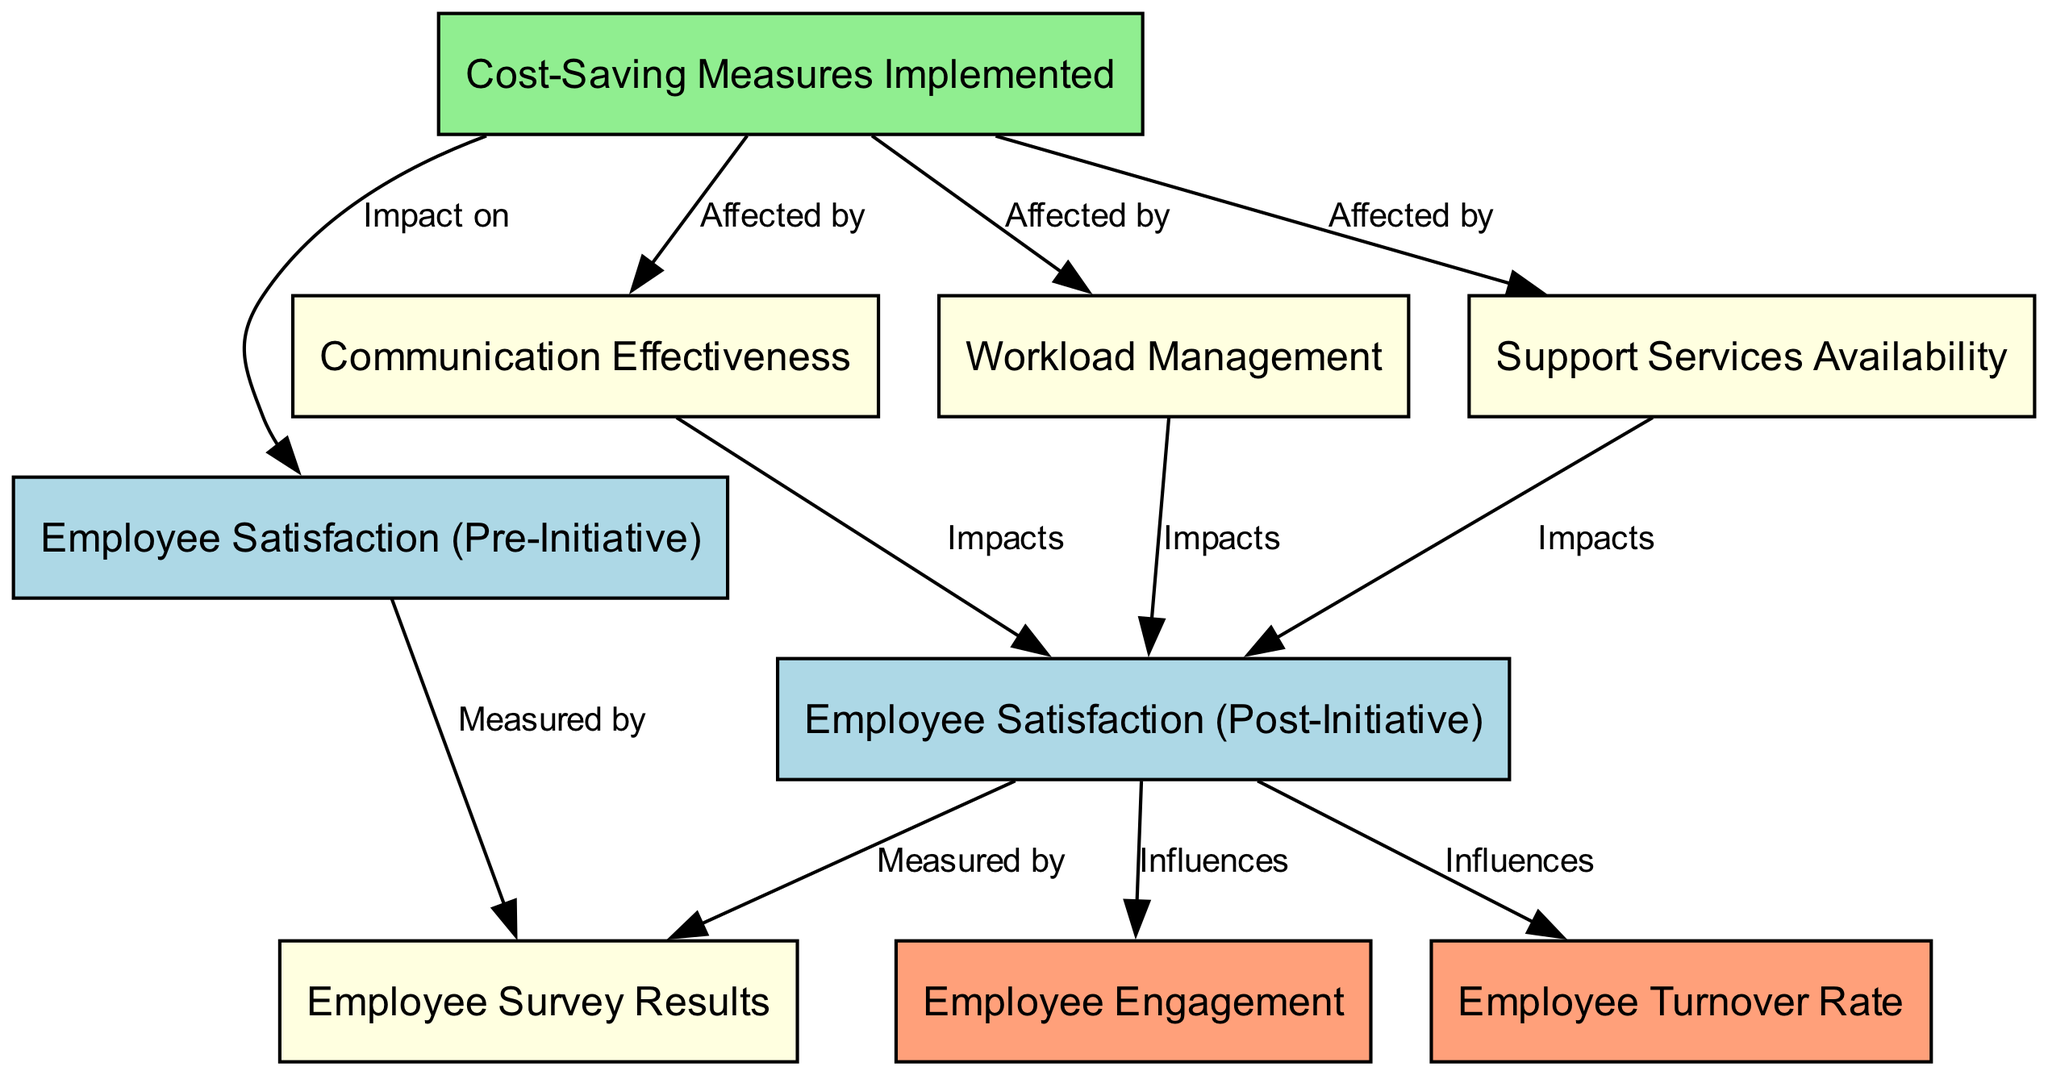What are the two main satisfaction levels represented in the diagram? The diagram represents two main satisfaction levels: employee satisfaction before the implementation of cost-saving initiatives and employee satisfaction after the implementation. These are identified as "Employee Satisfaction (Pre-Initiative)" and "Employee Satisfaction (Post-Initiative)" respectively.
Answer: Employee Satisfaction (Pre-Initiative), Employee Satisfaction (Post-Initiative) How many nodes are present in the diagram? To find the total number of nodes, we count each unique node listed in the 'nodes' section of the data. There are a total of nine nodes in the diagram.
Answer: 9 What is the relationship between cost-saving measures and pre-satisfaction? The diagram shows that cost-saving measures have an impact on pre-satisfaction. This is expressed with the edge labeled "Impact on" connecting "Cost-Saving Measures Implemented" to "Employee Satisfaction (Pre-Initiative)."
Answer: Impact on Which node influences employee engagement? The node that influences employee engagement is "Employee Satisfaction (Post-Initiative)." The diagram explicitly shows an edge leading from "Employee Satisfaction (Post-Initiative)" to "Employee Engagement" labeled "Influences."
Answer: Employee Satisfaction (Post-Initiative) What factors are affected by cost-saving measures? The diagram indicates three factors that are affected by cost-saving measures, represented by the edges leading to "Communication Effectiveness," "Workload Management," and "Support Services Availability." Therefore, all three are directly influenced by the cost-saving measures.
Answer: Communication Effectiveness, Workload Management, Support Services Availability How does communication effectiveness impact post-satisfaction? Communication effectiveness impacts post-satisfaction as shown by the edge connecting the two nodes in the diagram, labeled "Impacts." This indicates that improvements in communication can lead to higher employee satisfaction after the initiatives.
Answer: Impacts What measurement is used to evaluate both pre- and post-satisfaction? The evaluation of both pre-satisfaction and post-satisfaction is conducted through "Employee Survey Results." This is indicated by the edges connecting both "Employee Satisfaction (Pre-Initiative)" and "Employee Satisfaction (Post-Initiative)" to "Employee Survey Results," both labeled "Measured by."
Answer: Employee Survey Results What influences the employee turnover rate according to the diagram? The employee turnover rate is influenced by "Employee Satisfaction (Post-Initiative)." The diagram has a direct connection labeled "Influences" from "Employee Satisfaction (Post-Initiative)" to "Employee Turnover Rate."
Answer: Employee Satisfaction (Post-Initiative) 